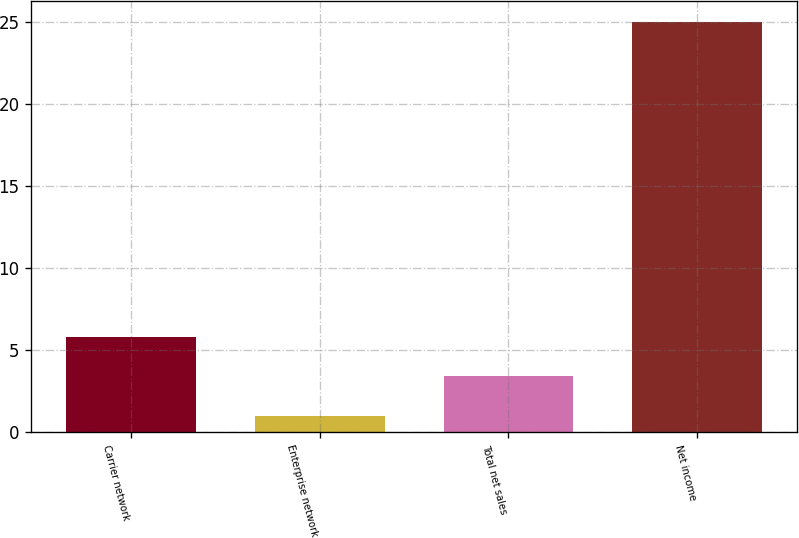Convert chart. <chart><loc_0><loc_0><loc_500><loc_500><bar_chart><fcel>Carrier network<fcel>Enterprise network<fcel>Total net sales<fcel>Net income<nl><fcel>5.8<fcel>1<fcel>3.4<fcel>25<nl></chart> 